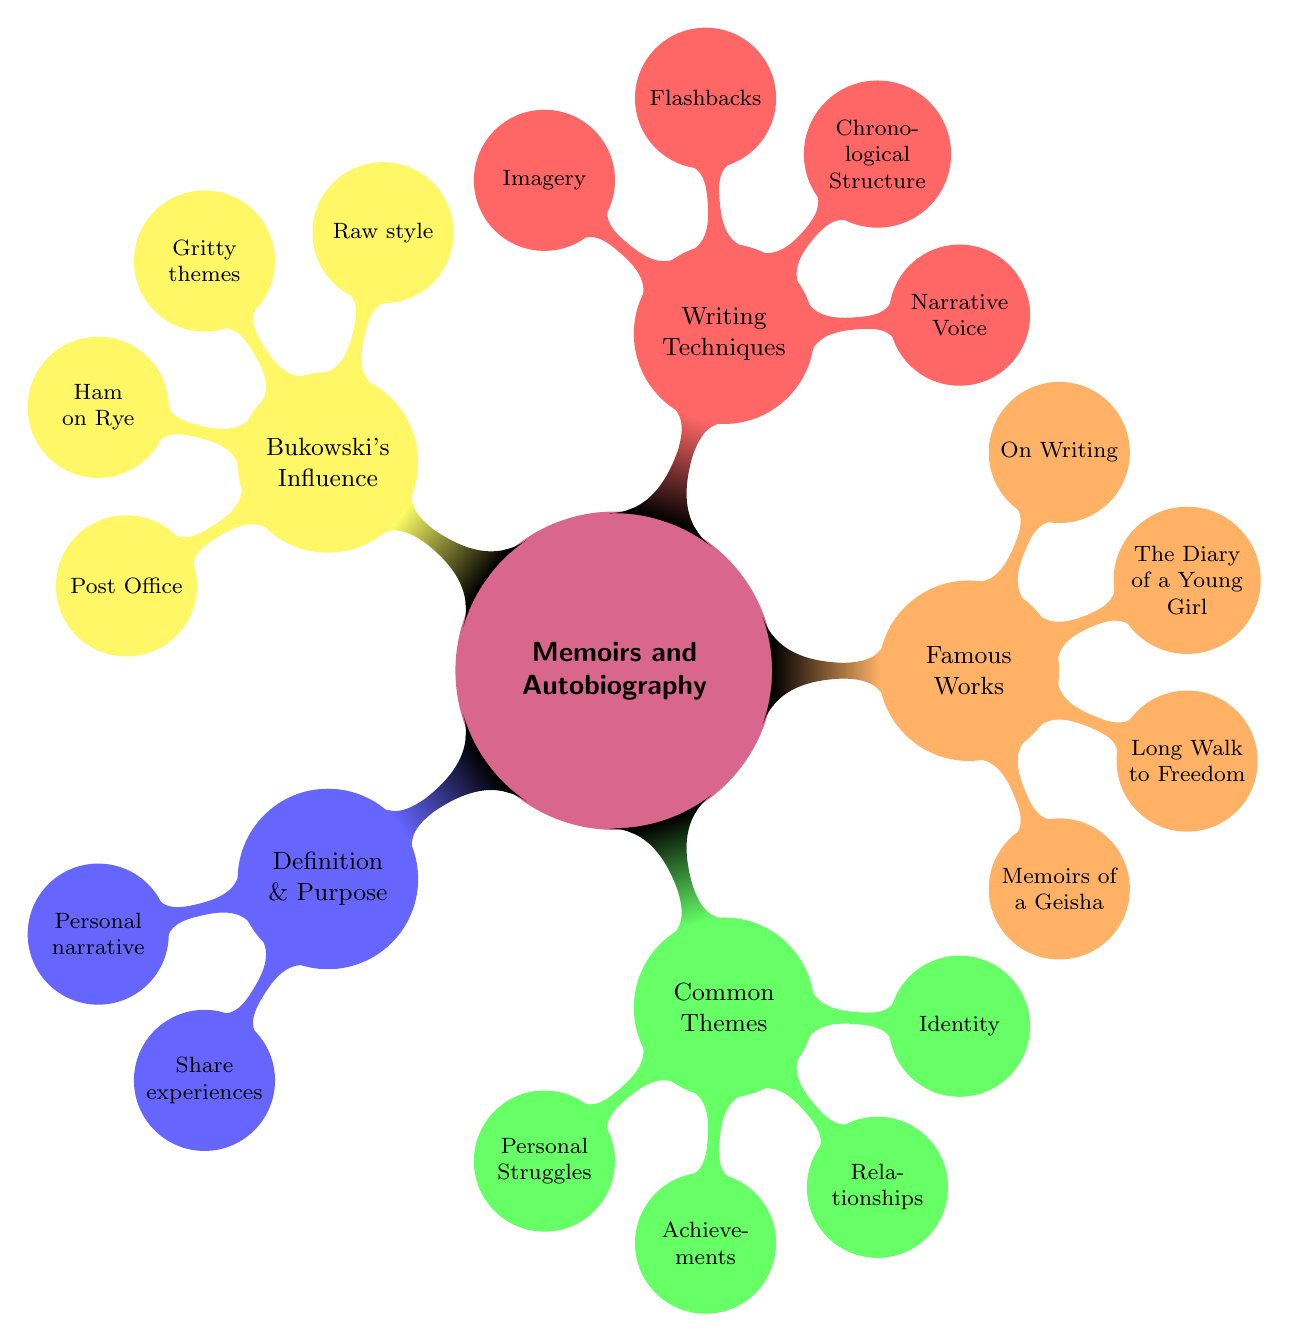What is the primary purpose of Memoirs and Autobiographies? The purpose of Memoirs and Autobiographies is to reflect on one's life, convey experiences and lessons, and connect with readers. This information can be found under the "Definition and Purpose" node in the diagram.
Answer: To reflect on one's life, convey experiences and lessons, and connect with readers How many Common Themes are listed in the diagram? The Common Themes section includes Personal Struggles, Achievements, Relationships, and Identity. Counting these nodes gives a total of four themes.
Answer: 4 What book is described as a young girl’s perspective on life during WWII? The book that fits this description is "The Diary of a Young Girl" written by Anne Frank. This is explicitly mentioned under the "Famous Memoirs and Autobiographies" node.
Answer: The Diary of a Young Girl Which writing technique involves revisiting past events? The technique that involves revisiting past events is called "Flashbacks." This is detailed under the "Writing Techniques" corresponding node in the diagram.
Answer: Flashbacks What common theme is associated with Charles Bukowski's writing? A common theme associated with Charles Bukowski’s writing is struggling with alcoholism. This theme is part of what defines his influence, mentioned under the "Bukowski's Influence" node.
Answer: Struggling with alcoholism What narrative style is recognized under Bukowski's Influence? The style recognized under Bukowski's Influence is "Raw style." This term sums up how his writing reflects the gritty aspects of life, which is noted in that specific node.
Answer: Raw style How is the narrative structure described in memoirs and autobiographies? The narrative structure in memoirs and autobiographies is described as "Chronological Structure." This is specifically mentioned under the "Writing Techniques" node, highlighting how events are ordered.
Answer: Chronological Structure Which work is a semi-autobiographical novel about Bukowski's early years? The work that is a semi-autobiographical novel about Bukowski's early years is titled "Ham on Rye." This information is explicitly provided in the "Works" sub-node under "Bukowski's Influence."
Answer: Ham on Rye 